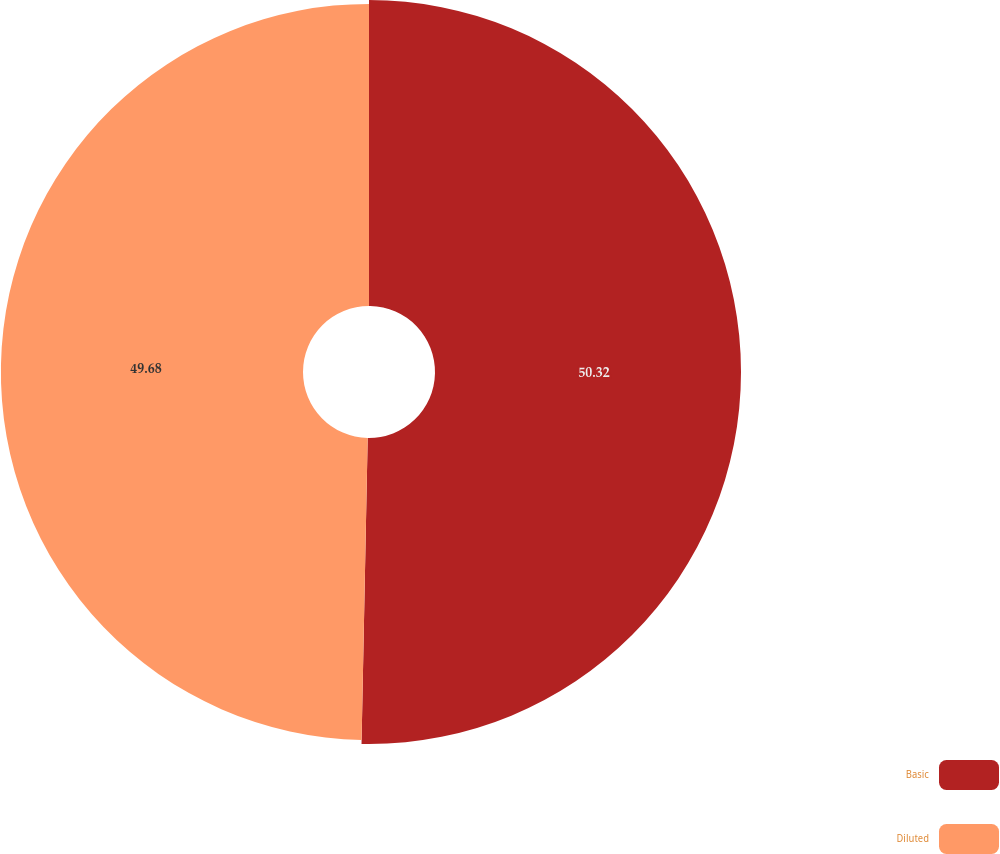<chart> <loc_0><loc_0><loc_500><loc_500><pie_chart><fcel>Basic<fcel>Diluted<nl><fcel>50.32%<fcel>49.68%<nl></chart> 